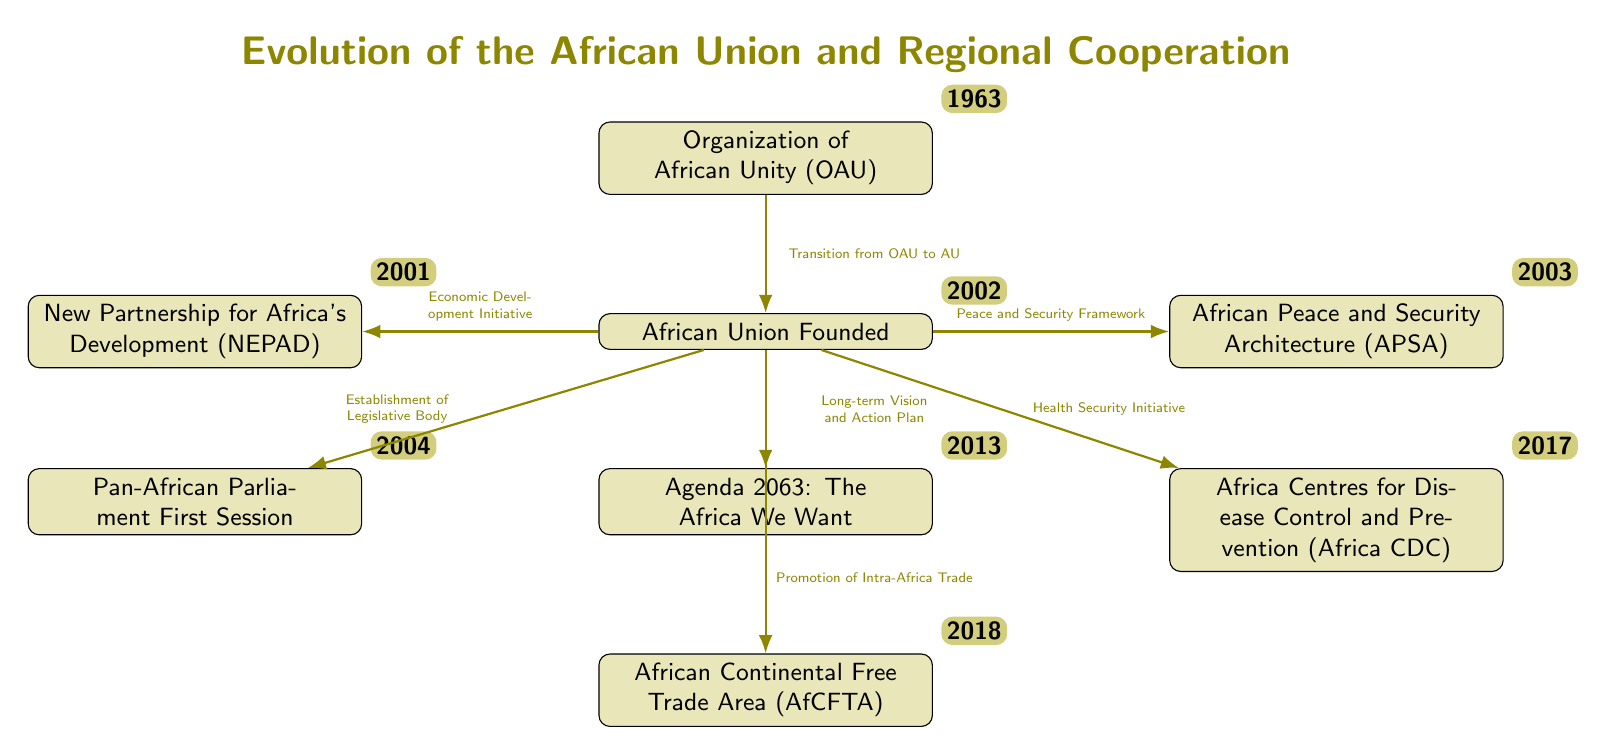What year was the Organization of African Unity (OAU) founded? According to the timeline in the diagram, the OAU was established in 1963, which is indicated next to the OAU event node.
Answer: 1963 What significant change occurred between the OAU and the African Union (AU)? The diagram shows a transition arrow from the OAU to the AU, indicating the formation of the AU and marking a shift in how regional cooperation was organized.
Answer: Transition from OAU to AU What was launched in 2001? The diagram indicates that NEPAD was established in 2001, placing the date next to the NEPAD event node.
Answer: New Partnership for Africa's Development (NEPAD) Which initiative promotes intra-Africa trade? The AfCFTA event node in the diagram specifically states that it promotes intra-Africa trade, and this is confirmed by the label connected to the arrow pointing from AU to AfCFTA.
Answer: African Continental Free Trade Area (AfCFTA) How many key initiatives are listed that stem from the African Union? By counting the arrows leading from the AU node to the various initiatives (NEPAD, APSA, PAP, Agenda 2063, Africa CDC, and AfCFTA), we find there are six initiatives.
Answer: 6 What is the main focus of the African Peace and Security Architecture (APSA)? The APSA is identified in the diagram with a label pointing to it from the AU, describing its role as the "Peace and Security Framework," indicating its focus on maintaining peace and security in Africa.
Answer: Peace and Security Framework Which initiative was established first after the AU was founded? The diagram shows that NEPAD was established in 2001, shortly after the AU's founding in 2002, making NEPAD the first key initiative listed following the AU.
Answer: New Partnership for Africa's Development (NEPAD) In what year did the Pan-African Parliament hold its first session? The diagram shows the year 2004, which is indicated next to the Pan-African Parliament event node.
Answer: 2004 What is the long-term vision and action plan introduced by the African Union? The diagram identifies Agenda 2063, positioned below the AU node, as the long-term vision and action plan, describing the aspirations for Africa's growth.
Answer: Agenda 2063: The Africa We Want 